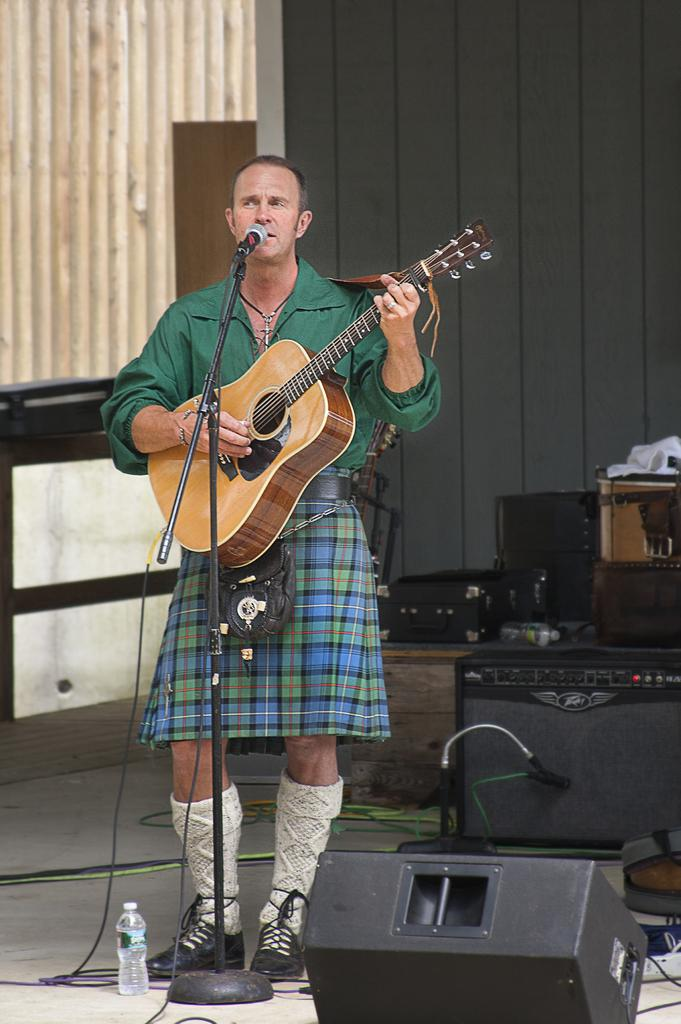What is the man in the image holding? The man is holding a guitar. What object is present for amplifying sound in the image? There is a microphone in the image. What color is the shirt the man is wearing? The man is wearing a green shirt. How many bottles can be seen in the image? There are three bottles in the image. What type of approval does the man receive from the news in the image? There is no news or approval present in the image; it only features a man holding a guitar, a microphone, and three bottles. 